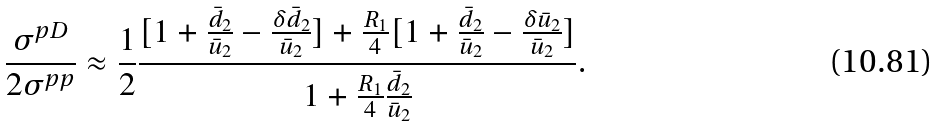<formula> <loc_0><loc_0><loc_500><loc_500>\frac { \sigma ^ { p D } } { 2 \sigma ^ { p p } } \approx \frac { 1 } { 2 } \frac { [ 1 + \frac { \bar { d } _ { 2 } } { \bar { u } _ { 2 } } - \frac { \delta \bar { d } _ { 2 } } { \bar { u } _ { 2 } } ] + \frac { R _ { 1 } } { 4 } [ 1 + \frac { \bar { d } _ { 2 } } { \bar { u } _ { 2 } } - \frac { \delta \bar { u } _ { 2 } } { \bar { u } _ { 2 } } ] } { 1 + \frac { R _ { 1 } } { 4 } \frac { \bar { d } _ { 2 } } { \bar { u } _ { 2 } } } .</formula> 